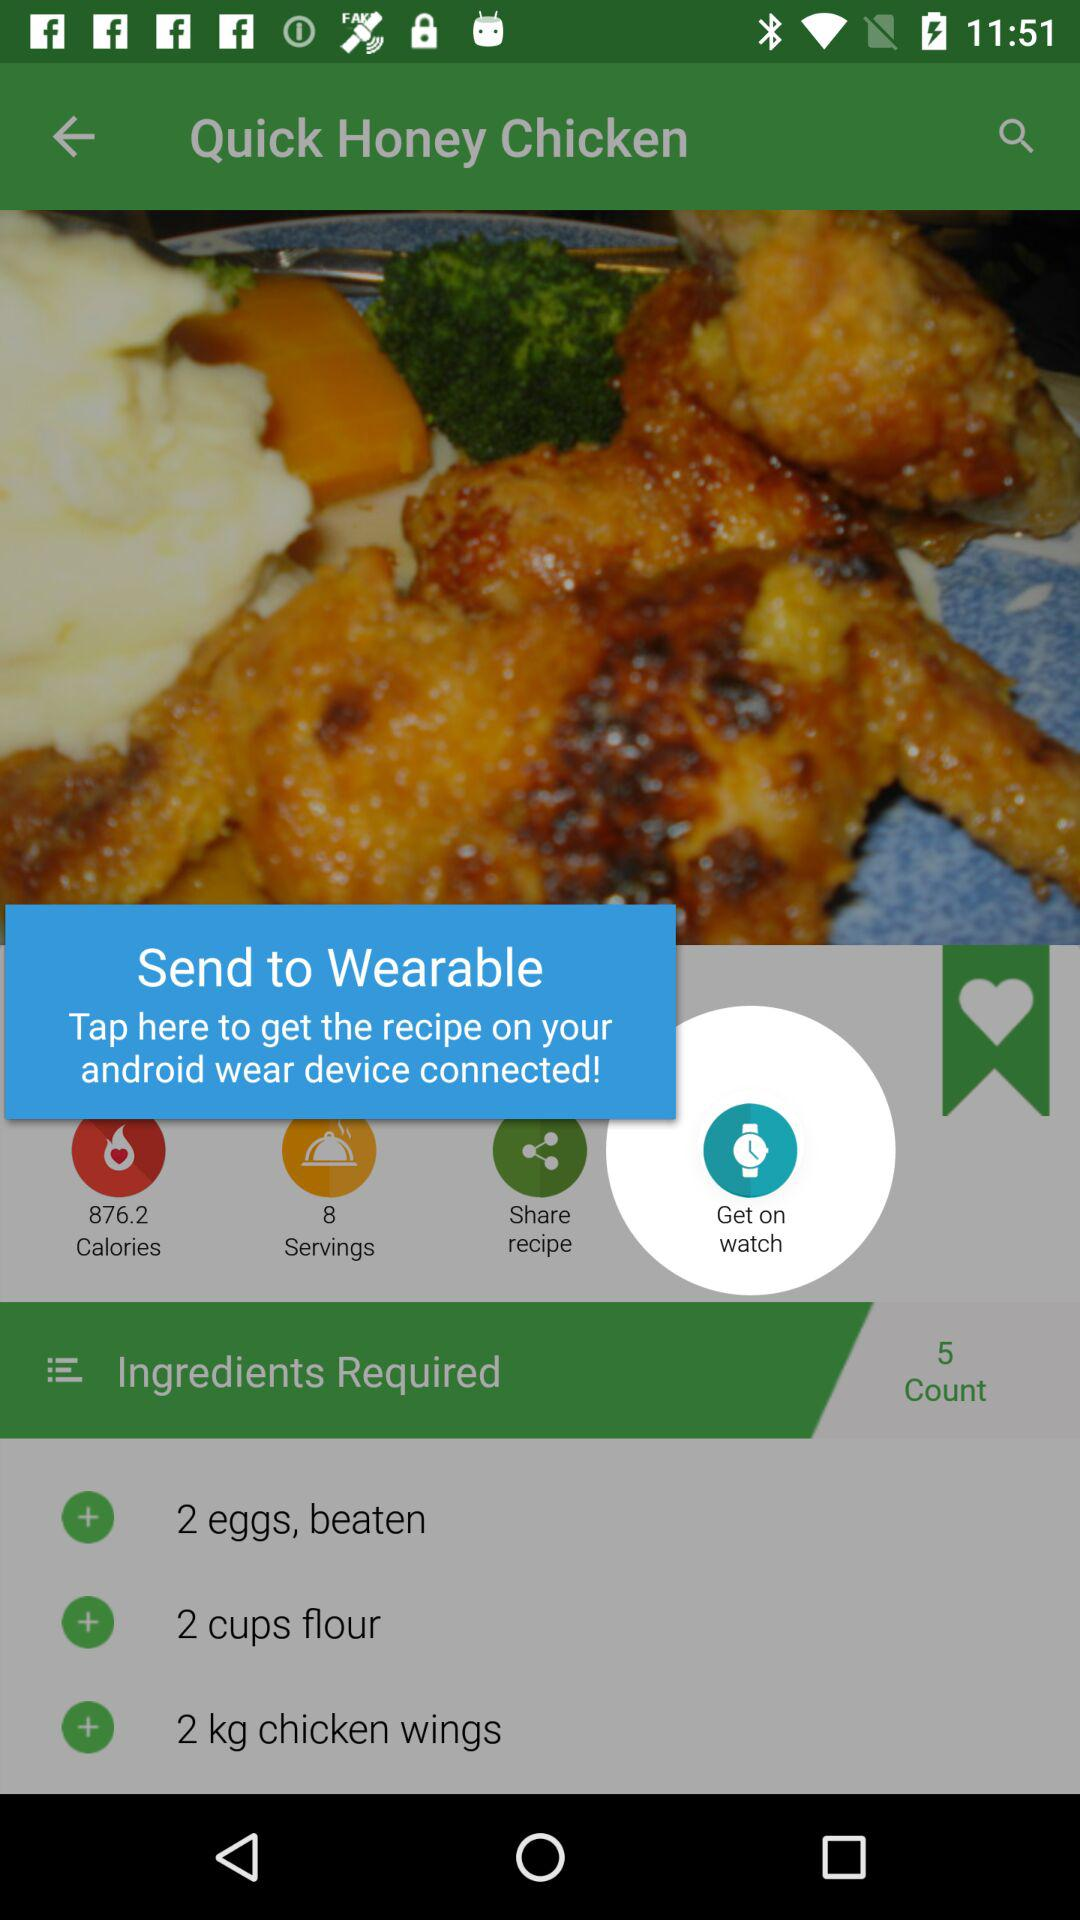How many calories are in the recipe?
Answer the question using a single word or phrase. 876.2 